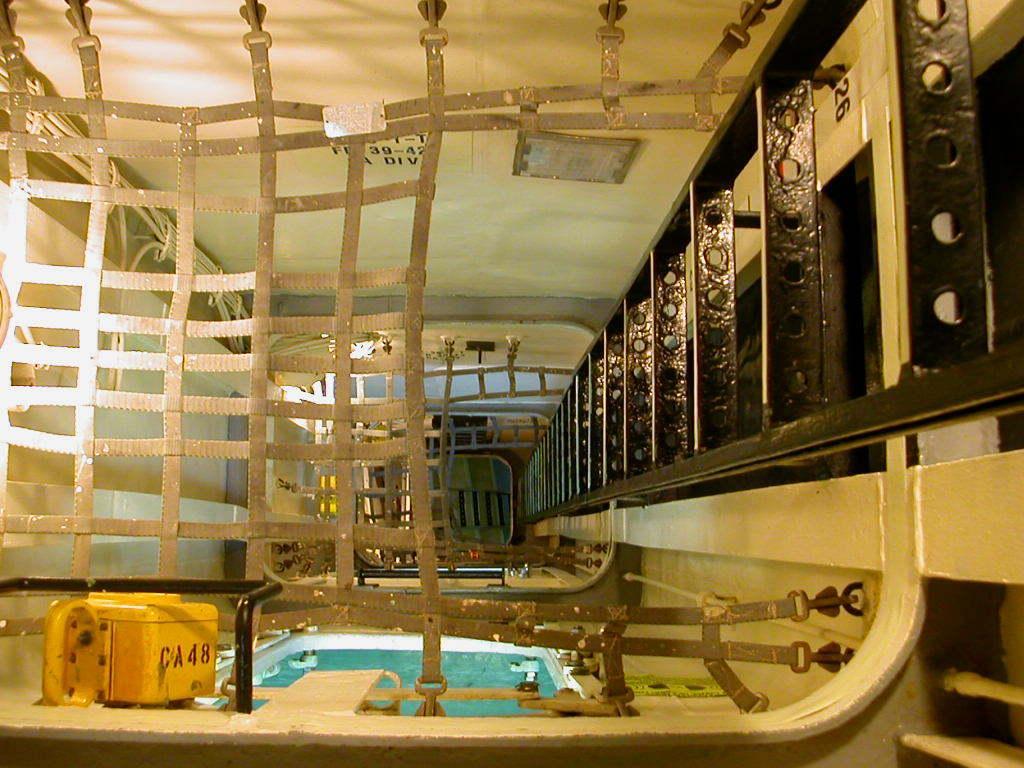How would you summarize this image in a sentence or two? There is a room in which this room is divided into cabins using these fence. The divided cabin has a swimming pool with some water in it. There is a railing on the right side of the image in the room. There is a yellow box in the room. 